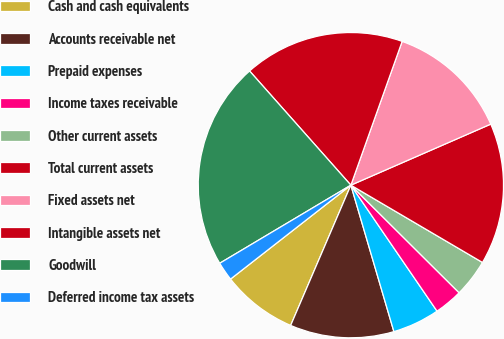<chart> <loc_0><loc_0><loc_500><loc_500><pie_chart><fcel>Cash and cash equivalents<fcel>Accounts receivable net<fcel>Prepaid expenses<fcel>Income taxes receivable<fcel>Other current assets<fcel>Total current assets<fcel>Fixed assets net<fcel>Intangible assets net<fcel>Goodwill<fcel>Deferred income tax assets<nl><fcel>8.0%<fcel>11.0%<fcel>5.0%<fcel>3.0%<fcel>4.0%<fcel>15.0%<fcel>13.0%<fcel>17.0%<fcel>22.0%<fcel>2.0%<nl></chart> 